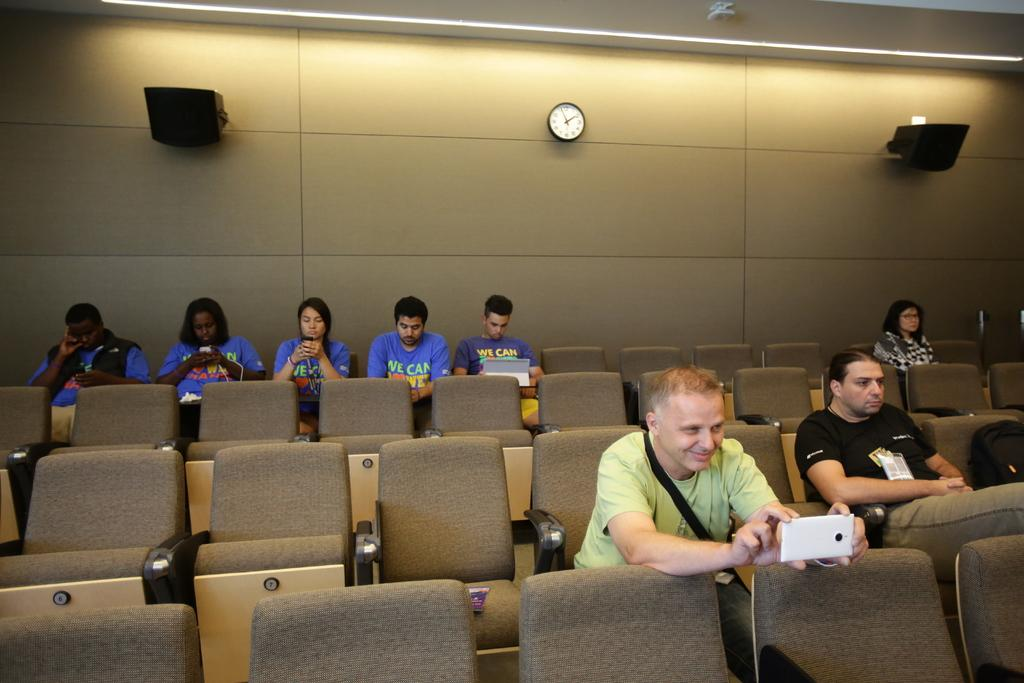<image>
Describe the image concisely. Some people sit wearing blue tee shirts with the words we can written on them. 